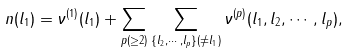Convert formula to latex. <formula><loc_0><loc_0><loc_500><loc_500>n ( l _ { 1 } ) = \nu ^ { ( 1 ) } ( l _ { 1 } ) + \sum _ { p ( \geq 2 ) } \sum _ { \{ l _ { 2 } , \cdots , l _ { p } \} ( \ne l _ { 1 } ) } \nu ^ { ( p ) } ( l _ { 1 } , l _ { 2 } , \cdots , l _ { p } ) ,</formula> 